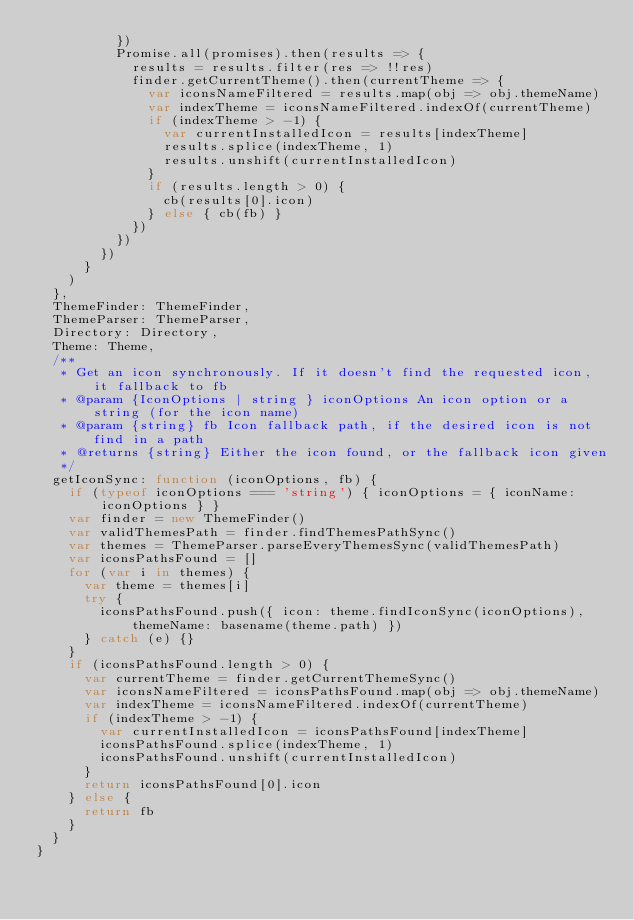<code> <loc_0><loc_0><loc_500><loc_500><_JavaScript_>          })
          Promise.all(promises).then(results => {
            results = results.filter(res => !!res)
            finder.getCurrentTheme().then(currentTheme => {
              var iconsNameFiltered = results.map(obj => obj.themeName)
              var indexTheme = iconsNameFiltered.indexOf(currentTheme)
              if (indexTheme > -1) {
                var currentInstalledIcon = results[indexTheme]
                results.splice(indexTheme, 1)
                results.unshift(currentInstalledIcon)
              }
              if (results.length > 0) {
                cb(results[0].icon)
              } else { cb(fb) }
            })
          })
        })
      }
    )
  },
  ThemeFinder: ThemeFinder,
  ThemeParser: ThemeParser,
  Directory: Directory,
  Theme: Theme,
  /**
   * Get an icon synchronously. If it doesn't find the requested icon, it fallback to fb
   * @param {IconOptions | string } iconOptions An icon option or a string (for the icon name)
   * @param {string} fb Icon fallback path, if the desired icon is not find in a path
   * @returns {string} Either the icon found, or the fallback icon given
   */
  getIconSync: function (iconOptions, fb) {
    if (typeof iconOptions === 'string') { iconOptions = { iconName: iconOptions } }
    var finder = new ThemeFinder()
    var validThemesPath = finder.findThemesPathSync()
    var themes = ThemeParser.parseEveryThemesSync(validThemesPath)
    var iconsPathsFound = []
    for (var i in themes) {
      var theme = themes[i]
      try {
        iconsPathsFound.push({ icon: theme.findIconSync(iconOptions), themeName: basename(theme.path) })
      } catch (e) {}
    }
    if (iconsPathsFound.length > 0) {
      var currentTheme = finder.getCurrentThemeSync()
      var iconsNameFiltered = iconsPathsFound.map(obj => obj.themeName)
      var indexTheme = iconsNameFiltered.indexOf(currentTheme)
      if (indexTheme > -1) {
        var currentInstalledIcon = iconsPathsFound[indexTheme]
        iconsPathsFound.splice(indexTheme, 1)
        iconsPathsFound.unshift(currentInstalledIcon)
      }
      return iconsPathsFound[0].icon
    } else {
      return fb
    }
  }
}
</code> 